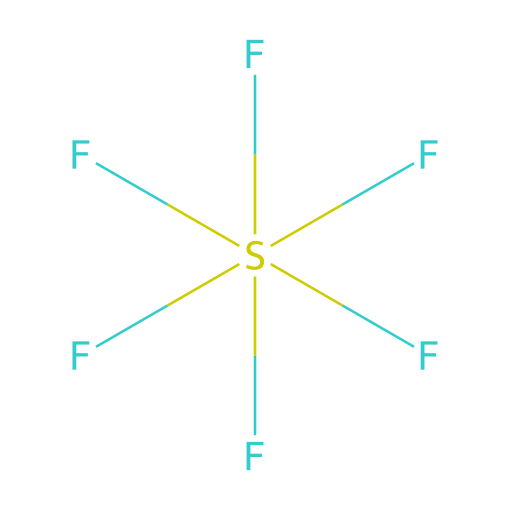how many atoms are in sulfur hexafluoride? In the given SMILES representation, F[S](F)(F)(F)(F)F, we can count the number of atoms. The sulfur (S) atom counts as one, and there are six fluorine (F) atoms. Thus, the total number of atoms is 7.
Answer: 7 what is the central atom in sulfur hexafluoride? The structure shows that sulfur (S) is at the center, with fluorine (F) atoms surrounding it. This indicates that sulfur is the central atom for this molecule.
Answer: sulfur how many bonds does sulfur form in sulfur hexafluoride? Each fluorine (F) atom forms a single bond with the central sulfur (S) atom. Since there are six fluorine atoms, sulfur forms six bonds in total.
Answer: 6 what type of compound is sulfur hexafluoride? Sulfur hexafluoride falls under the category of hypervalent molecules due to the central sulfur atom forming more than four bonds to surrounding atoms (in this case, six fluorine atoms).
Answer: hypervalent why is sulfur in sulfur hexafluoride hypervalent? In this molecule, sulfur has six bonding pairs of electrons with the fluorine atoms, which exceeds the typical four that most elements in the second period can accommodate. This means sulfur can expand its valence shell to hold more than eight electrons, which is characteristic of hypervalency.
Answer: because it has six bonds what is the shape of the molecule sulfur hexafluoride? The molecular geometry of sulfur hexafluoride is octahedral, which is inferred from the arrangement of the six fluorine atoms evenly spaced around the central sulfur atom.
Answer: octahedral how many valence electrons does sulfur have in sulfur hexafluoride? Sulfur (S) is in Group 16 of the periodic table, which means it has six valence electrons. This property plays a role in its ability to form multiple bonds within this hypervalent compound.
Answer: 6 